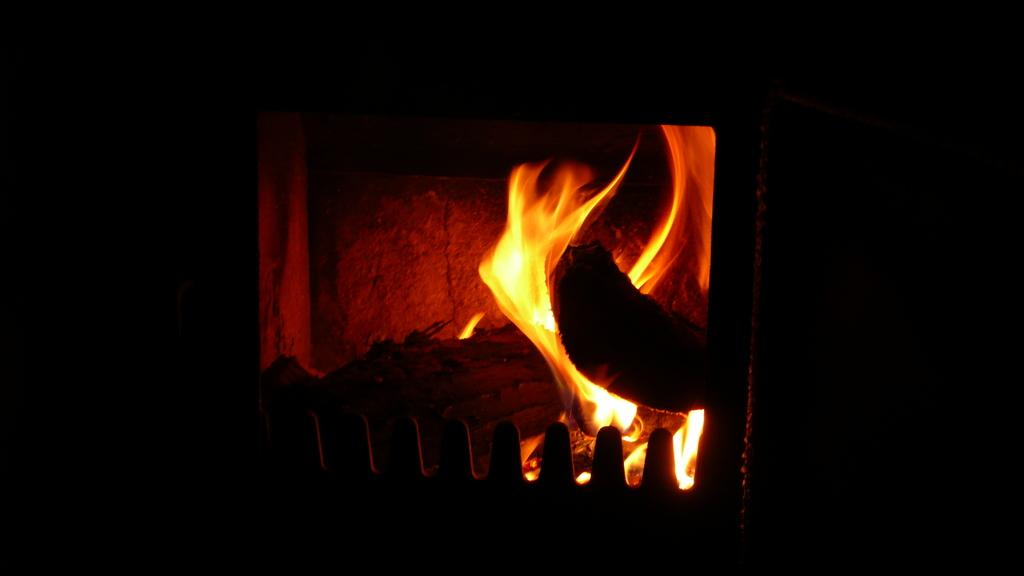What is the main subject of the image? The main subject of the image is a flame. Can you describe the location of the flame in the image? The flame is in the middle of the image. What type of smoke can be seen coming from the drain in the image? There is no drain present in the image, and therefore no smoke can be observed. 